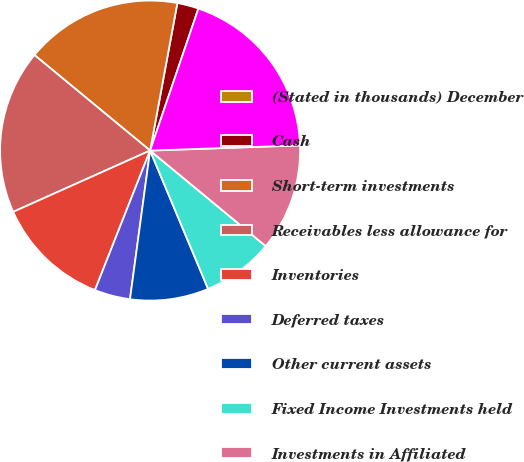Convert chart. <chart><loc_0><loc_0><loc_500><loc_500><pie_chart><fcel>(Stated in thousands) December<fcel>Cash<fcel>Short-term investments<fcel>Receivables less allowance for<fcel>Inventories<fcel>Deferred taxes<fcel>Other current assets<fcel>Fixed Income Investments held<fcel>Investments in Affiliated<fcel>Fixed Assets less accumulated<nl><fcel>0.0%<fcel>2.31%<fcel>16.92%<fcel>17.69%<fcel>12.31%<fcel>3.85%<fcel>8.46%<fcel>7.69%<fcel>11.54%<fcel>19.23%<nl></chart> 